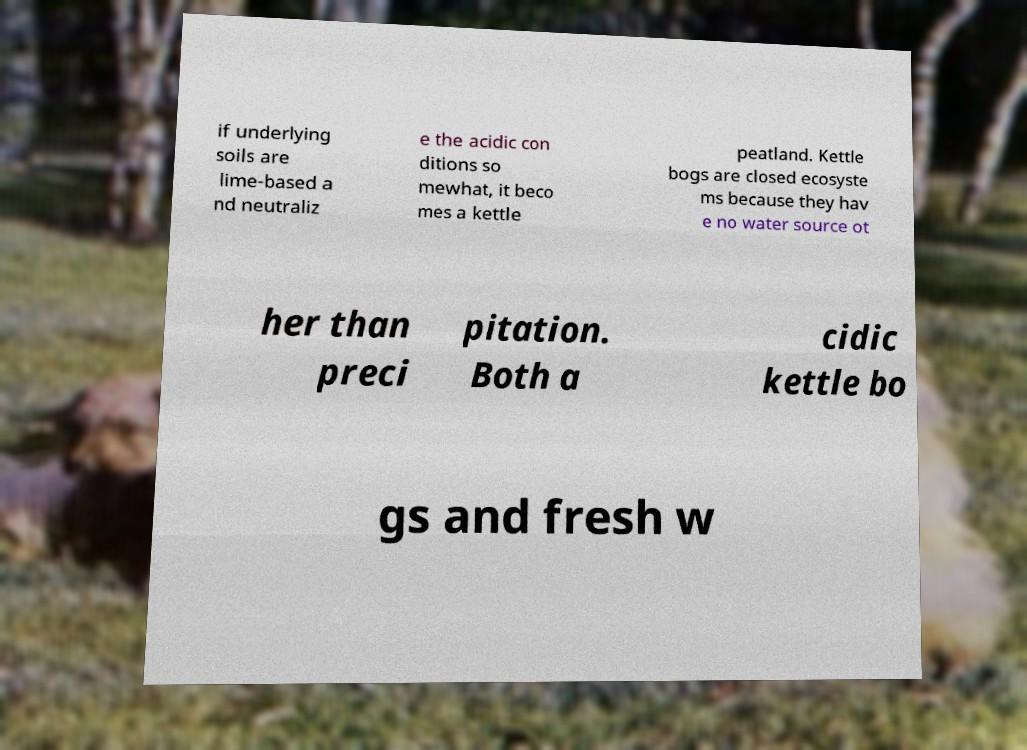Please read and relay the text visible in this image. What does it say? if underlying soils are lime-based a nd neutraliz e the acidic con ditions so mewhat, it beco mes a kettle peatland. Kettle bogs are closed ecosyste ms because they hav e no water source ot her than preci pitation. Both a cidic kettle bo gs and fresh w 